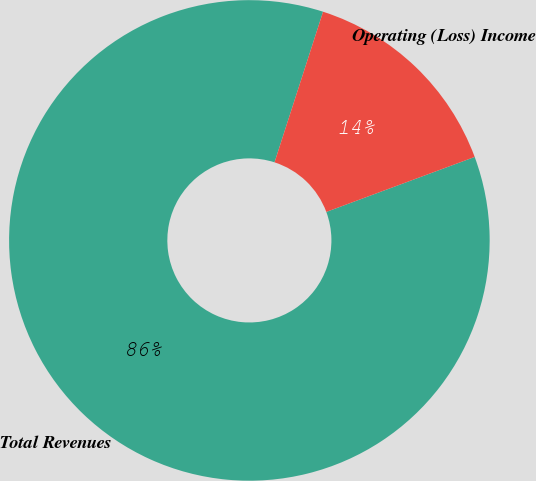Convert chart. <chart><loc_0><loc_0><loc_500><loc_500><pie_chart><fcel>Total Revenues<fcel>Operating (Loss) Income<nl><fcel>85.61%<fcel>14.39%<nl></chart> 